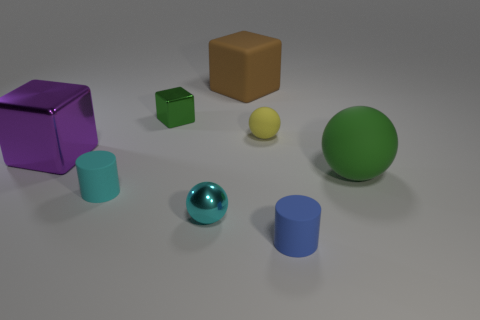Add 2 large blue blocks. How many objects exist? 10 Subtract all cylinders. How many objects are left? 6 Add 5 tiny cyan things. How many tiny cyan things are left? 7 Add 6 cyan balls. How many cyan balls exist? 7 Subtract 0 yellow cylinders. How many objects are left? 8 Subtract all brown shiny blocks. Subtract all blue cylinders. How many objects are left? 7 